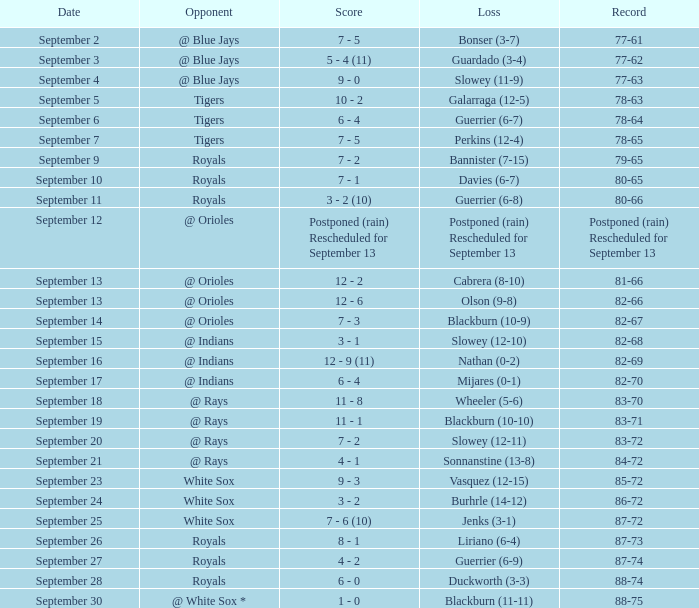What score has the opponent of tigers and a record of 78-64? 6 - 4. 